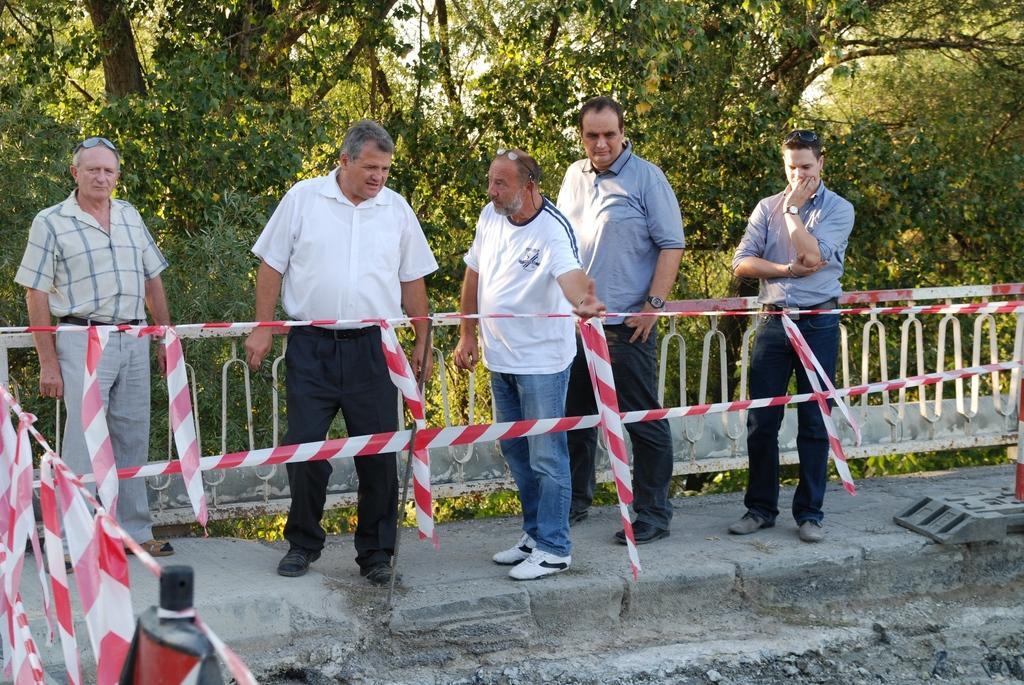How would you summarize this image in a sentence or two? In the foreground of this image, there are five men standing on the path and there is a safety poles in front of them. In the background, there are trees and a railing. 